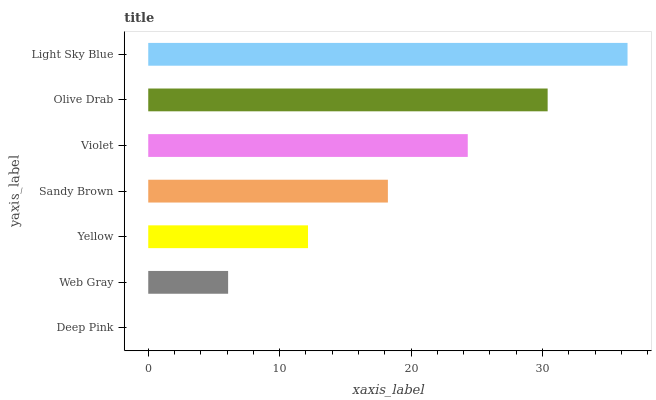Is Deep Pink the minimum?
Answer yes or no. Yes. Is Light Sky Blue the maximum?
Answer yes or no. Yes. Is Web Gray the minimum?
Answer yes or no. No. Is Web Gray the maximum?
Answer yes or no. No. Is Web Gray greater than Deep Pink?
Answer yes or no. Yes. Is Deep Pink less than Web Gray?
Answer yes or no. Yes. Is Deep Pink greater than Web Gray?
Answer yes or no. No. Is Web Gray less than Deep Pink?
Answer yes or no. No. Is Sandy Brown the high median?
Answer yes or no. Yes. Is Sandy Brown the low median?
Answer yes or no. Yes. Is Deep Pink the high median?
Answer yes or no. No. Is Deep Pink the low median?
Answer yes or no. No. 